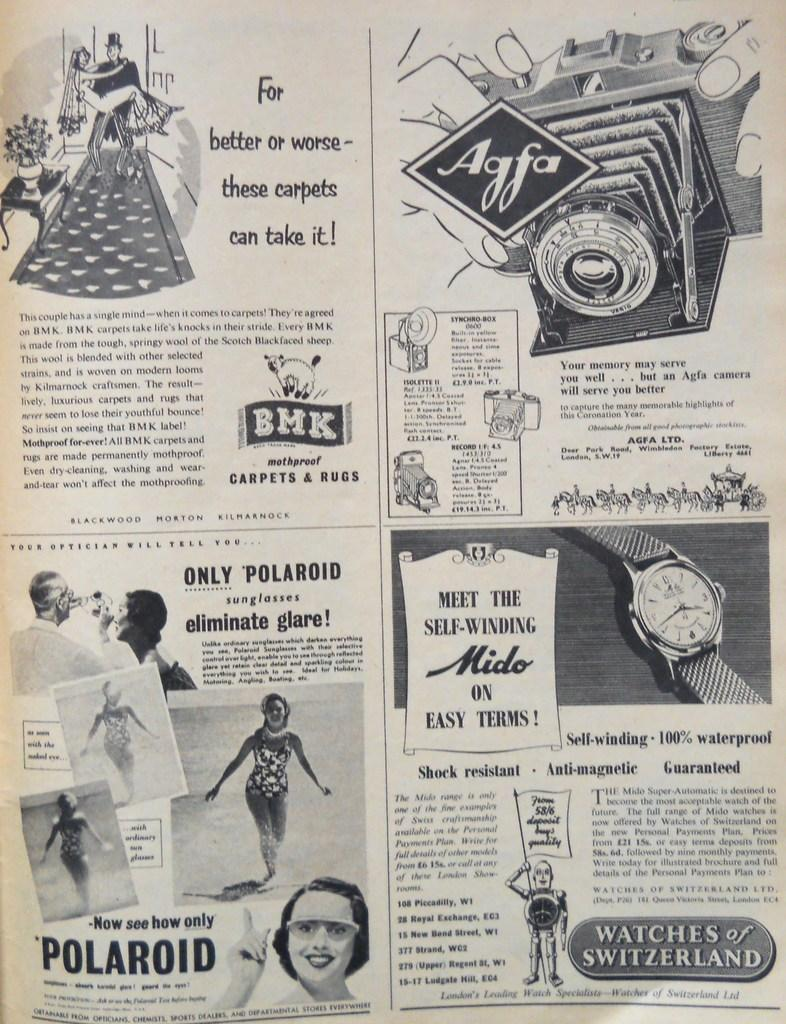<image>
Relay a brief, clear account of the picture shown. A page of an old advertisement that has an ad for Polaroid and BMK Carpets and Rugs. 